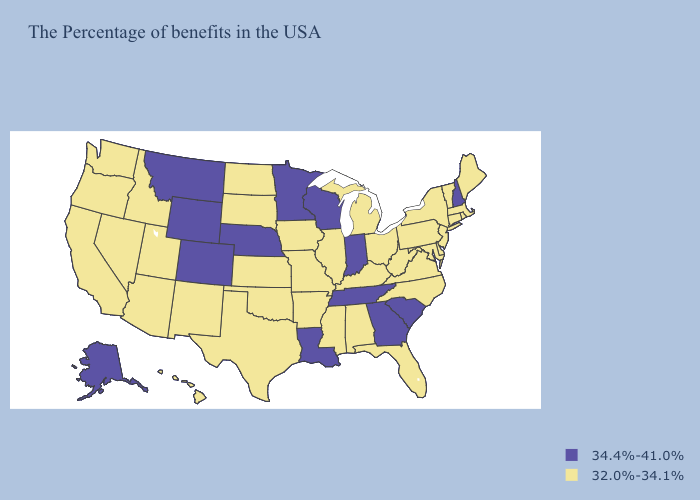What is the lowest value in the MidWest?
Answer briefly. 32.0%-34.1%. What is the value of Georgia?
Keep it brief. 34.4%-41.0%. Name the states that have a value in the range 34.4%-41.0%?
Concise answer only. New Hampshire, South Carolina, Georgia, Indiana, Tennessee, Wisconsin, Louisiana, Minnesota, Nebraska, Wyoming, Colorado, Montana, Alaska. What is the value of South Carolina?
Quick response, please. 34.4%-41.0%. How many symbols are there in the legend?
Concise answer only. 2. Among the states that border Pennsylvania , which have the lowest value?
Be succinct. New York, New Jersey, Delaware, Maryland, West Virginia, Ohio. Does the map have missing data?
Quick response, please. No. Is the legend a continuous bar?
Concise answer only. No. Does New Hampshire have the lowest value in the Northeast?
Write a very short answer. No. What is the value of Virginia?
Be succinct. 32.0%-34.1%. How many symbols are there in the legend?
Concise answer only. 2. Name the states that have a value in the range 34.4%-41.0%?
Quick response, please. New Hampshire, South Carolina, Georgia, Indiana, Tennessee, Wisconsin, Louisiana, Minnesota, Nebraska, Wyoming, Colorado, Montana, Alaska. Which states have the lowest value in the USA?
Quick response, please. Maine, Massachusetts, Rhode Island, Vermont, Connecticut, New York, New Jersey, Delaware, Maryland, Pennsylvania, Virginia, North Carolina, West Virginia, Ohio, Florida, Michigan, Kentucky, Alabama, Illinois, Mississippi, Missouri, Arkansas, Iowa, Kansas, Oklahoma, Texas, South Dakota, North Dakota, New Mexico, Utah, Arizona, Idaho, Nevada, California, Washington, Oregon, Hawaii. What is the highest value in the USA?
Keep it brief. 34.4%-41.0%. Among the states that border Vermont , does New Hampshire have the lowest value?
Be succinct. No. 